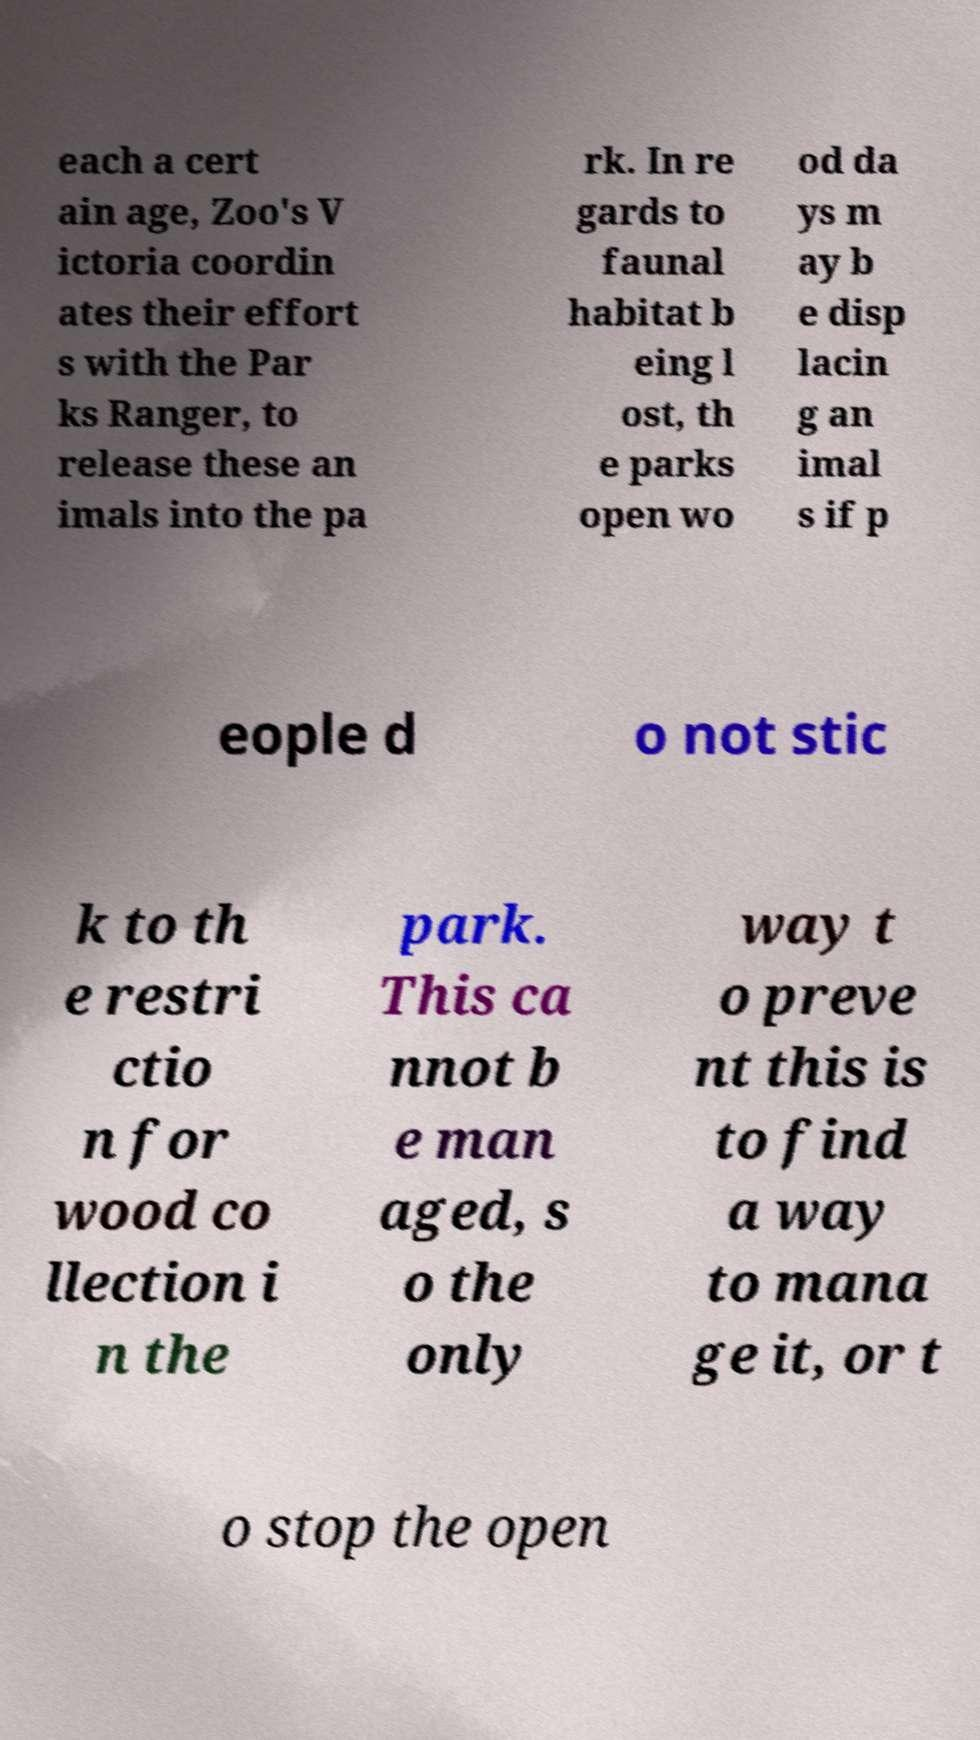Could you assist in decoding the text presented in this image and type it out clearly? each a cert ain age, Zoo's V ictoria coordin ates their effort s with the Par ks Ranger, to release these an imals into the pa rk. In re gards to faunal habitat b eing l ost, th e parks open wo od da ys m ay b e disp lacin g an imal s if p eople d o not stic k to th e restri ctio n for wood co llection i n the park. This ca nnot b e man aged, s o the only way t o preve nt this is to find a way to mana ge it, or t o stop the open 